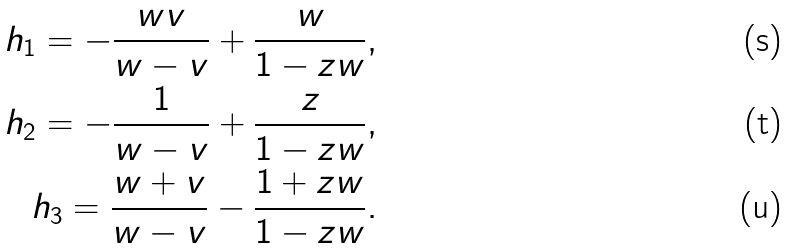Convert formula to latex. <formula><loc_0><loc_0><loc_500><loc_500>h _ { 1 } = - \frac { w v } { w - v } + \frac { w } { 1 - z w } , \\ h _ { 2 } = - \frac { 1 } { w - v } + \frac { z } { 1 - z w } , \\ h _ { 3 } = \frac { w + v } { w - v } - \frac { 1 + z w } { 1 - z w } .</formula> 